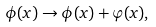<formula> <loc_0><loc_0><loc_500><loc_500>\phi ( x ) \to \phi ( x ) + \varphi ( x ) ,</formula> 